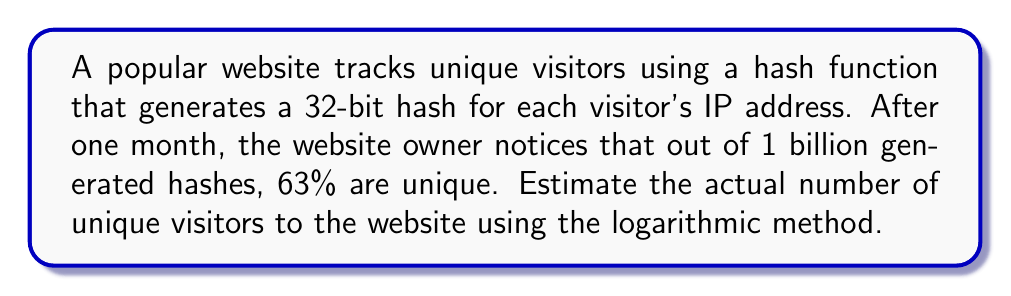What is the answer to this math problem? To solve this problem, we'll use the logarithmic method based on the birthday paradox. Let's break it down step-by-step:

1) Let $n$ be the number of unique visitors, and $m$ be the total number of possible hash values (in this case, $2^{32}$).

2) The probability of a collision (non-unique hash) is approximately:

   $$p \approx 1 - e^{-\frac{n^2}{2m}}$$

3) We're given that 63% of hashes are unique, so 37% are collisions. Therefore:

   $$0.37 \approx 1 - e^{-\frac{n^2}{2 \cdot 2^{32}}}$$

4) Solving for $n$:

   $$e^{-\frac{n^2}{2 \cdot 2^{32}}} \approx 0.63$$

   $$-\frac{n^2}{2 \cdot 2^{32}} \approx \ln(0.63)$$

   $$n^2 \approx -2 \cdot 2^{32} \cdot \ln(0.63)$$

   $$n \approx \sqrt{-2 \cdot 2^{32} \cdot \ln(0.63)}$$

5) Calculating:

   $$n \approx \sqrt{-2 \cdot 4,294,967,296 \cdot (-0.46204)}$$
   
   $$n \approx \sqrt{3,968,439,512}$$
   
   $$n \approx 1,992,094$$

Therefore, we estimate approximately 1,992,094 unique visitors to the website.
Answer: $1,992,094$ unique visitors 